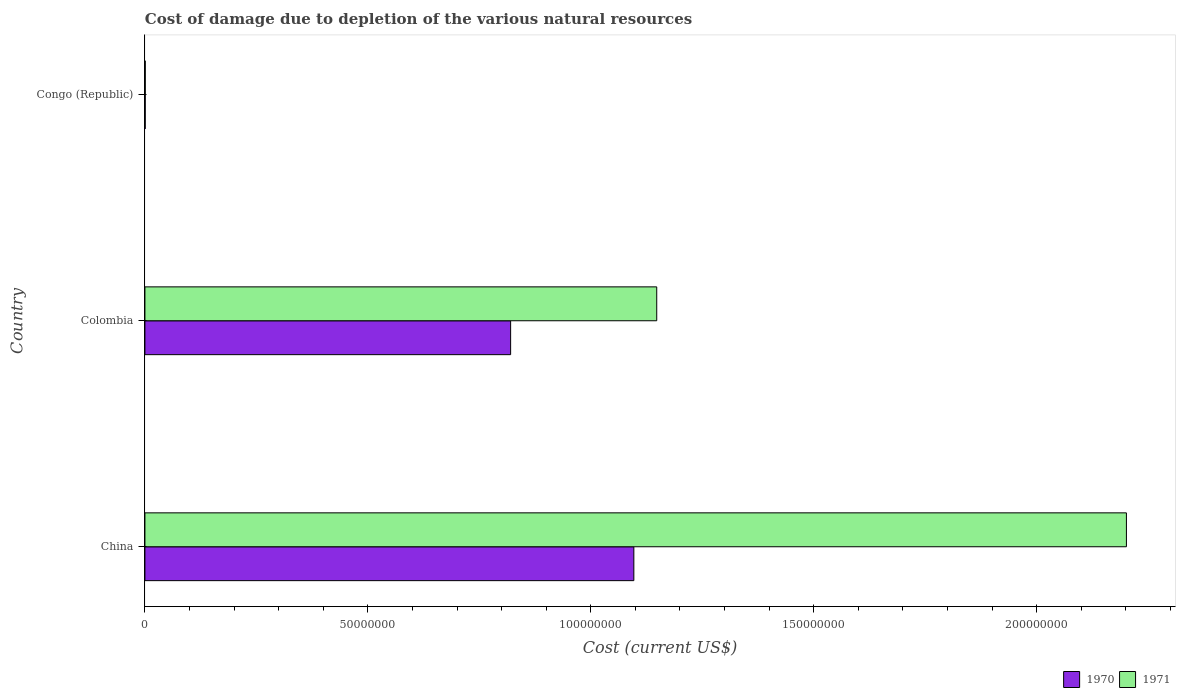Are the number of bars on each tick of the Y-axis equal?
Your answer should be compact. Yes. How many bars are there on the 3rd tick from the top?
Your answer should be compact. 2. What is the label of the 2nd group of bars from the top?
Provide a succinct answer. Colombia. What is the cost of damage caused due to the depletion of various natural resources in 1970 in Congo (Republic)?
Offer a very short reply. 6.34e+04. Across all countries, what is the maximum cost of damage caused due to the depletion of various natural resources in 1971?
Provide a succinct answer. 2.20e+08. Across all countries, what is the minimum cost of damage caused due to the depletion of various natural resources in 1971?
Provide a short and direct response. 7.34e+04. In which country was the cost of damage caused due to the depletion of various natural resources in 1971 maximum?
Your answer should be very brief. China. In which country was the cost of damage caused due to the depletion of various natural resources in 1971 minimum?
Your answer should be very brief. Congo (Republic). What is the total cost of damage caused due to the depletion of various natural resources in 1970 in the graph?
Provide a short and direct response. 1.92e+08. What is the difference between the cost of damage caused due to the depletion of various natural resources in 1971 in Colombia and that in Congo (Republic)?
Offer a terse response. 1.15e+08. What is the difference between the cost of damage caused due to the depletion of various natural resources in 1971 in China and the cost of damage caused due to the depletion of various natural resources in 1970 in Congo (Republic)?
Your answer should be compact. 2.20e+08. What is the average cost of damage caused due to the depletion of various natural resources in 1970 per country?
Offer a terse response. 6.39e+07. What is the difference between the cost of damage caused due to the depletion of various natural resources in 1970 and cost of damage caused due to the depletion of various natural resources in 1971 in Colombia?
Give a very brief answer. -3.28e+07. In how many countries, is the cost of damage caused due to the depletion of various natural resources in 1970 greater than 110000000 US$?
Provide a short and direct response. 0. What is the ratio of the cost of damage caused due to the depletion of various natural resources in 1971 in China to that in Congo (Republic)?
Your answer should be very brief. 2997.27. Is the difference between the cost of damage caused due to the depletion of various natural resources in 1970 in Colombia and Congo (Republic) greater than the difference between the cost of damage caused due to the depletion of various natural resources in 1971 in Colombia and Congo (Republic)?
Ensure brevity in your answer.  No. What is the difference between the highest and the second highest cost of damage caused due to the depletion of various natural resources in 1970?
Your answer should be compact. 2.76e+07. What is the difference between the highest and the lowest cost of damage caused due to the depletion of various natural resources in 1971?
Offer a terse response. 2.20e+08. Is the sum of the cost of damage caused due to the depletion of various natural resources in 1971 in Colombia and Congo (Republic) greater than the maximum cost of damage caused due to the depletion of various natural resources in 1970 across all countries?
Your response must be concise. Yes. What does the 2nd bar from the top in Congo (Republic) represents?
Your answer should be compact. 1970. What does the 1st bar from the bottom in China represents?
Give a very brief answer. 1970. How many bars are there?
Provide a short and direct response. 6. Are all the bars in the graph horizontal?
Your answer should be compact. Yes. How many countries are there in the graph?
Your answer should be compact. 3. Does the graph contain grids?
Ensure brevity in your answer.  No. Where does the legend appear in the graph?
Give a very brief answer. Bottom right. How many legend labels are there?
Your answer should be very brief. 2. How are the legend labels stacked?
Ensure brevity in your answer.  Horizontal. What is the title of the graph?
Ensure brevity in your answer.  Cost of damage due to depletion of the various natural resources. What is the label or title of the X-axis?
Ensure brevity in your answer.  Cost (current US$). What is the label or title of the Y-axis?
Your answer should be compact. Country. What is the Cost (current US$) in 1970 in China?
Offer a terse response. 1.10e+08. What is the Cost (current US$) of 1971 in China?
Provide a succinct answer. 2.20e+08. What is the Cost (current US$) in 1970 in Colombia?
Provide a short and direct response. 8.20e+07. What is the Cost (current US$) of 1971 in Colombia?
Give a very brief answer. 1.15e+08. What is the Cost (current US$) in 1970 in Congo (Republic)?
Offer a terse response. 6.34e+04. What is the Cost (current US$) of 1971 in Congo (Republic)?
Your response must be concise. 7.34e+04. Across all countries, what is the maximum Cost (current US$) of 1970?
Offer a very short reply. 1.10e+08. Across all countries, what is the maximum Cost (current US$) in 1971?
Give a very brief answer. 2.20e+08. Across all countries, what is the minimum Cost (current US$) of 1970?
Give a very brief answer. 6.34e+04. Across all countries, what is the minimum Cost (current US$) in 1971?
Keep it short and to the point. 7.34e+04. What is the total Cost (current US$) of 1970 in the graph?
Provide a short and direct response. 1.92e+08. What is the total Cost (current US$) of 1971 in the graph?
Provide a succinct answer. 3.35e+08. What is the difference between the Cost (current US$) in 1970 in China and that in Colombia?
Your answer should be compact. 2.76e+07. What is the difference between the Cost (current US$) of 1971 in China and that in Colombia?
Your answer should be compact. 1.05e+08. What is the difference between the Cost (current US$) of 1970 in China and that in Congo (Republic)?
Provide a short and direct response. 1.10e+08. What is the difference between the Cost (current US$) of 1971 in China and that in Congo (Republic)?
Ensure brevity in your answer.  2.20e+08. What is the difference between the Cost (current US$) of 1970 in Colombia and that in Congo (Republic)?
Keep it short and to the point. 8.20e+07. What is the difference between the Cost (current US$) of 1971 in Colombia and that in Congo (Republic)?
Your answer should be very brief. 1.15e+08. What is the difference between the Cost (current US$) of 1970 in China and the Cost (current US$) of 1971 in Colombia?
Provide a short and direct response. -5.13e+06. What is the difference between the Cost (current US$) in 1970 in China and the Cost (current US$) in 1971 in Congo (Republic)?
Offer a terse response. 1.10e+08. What is the difference between the Cost (current US$) of 1970 in Colombia and the Cost (current US$) of 1971 in Congo (Republic)?
Keep it short and to the point. 8.19e+07. What is the average Cost (current US$) of 1970 per country?
Make the answer very short. 6.39e+07. What is the average Cost (current US$) in 1971 per country?
Your answer should be compact. 1.12e+08. What is the difference between the Cost (current US$) of 1970 and Cost (current US$) of 1971 in China?
Provide a succinct answer. -1.10e+08. What is the difference between the Cost (current US$) in 1970 and Cost (current US$) in 1971 in Colombia?
Offer a terse response. -3.28e+07. What is the difference between the Cost (current US$) in 1970 and Cost (current US$) in 1971 in Congo (Republic)?
Your response must be concise. -1.00e+04. What is the ratio of the Cost (current US$) in 1970 in China to that in Colombia?
Provide a short and direct response. 1.34. What is the ratio of the Cost (current US$) in 1971 in China to that in Colombia?
Offer a very short reply. 1.92. What is the ratio of the Cost (current US$) in 1970 in China to that in Congo (Republic)?
Offer a terse response. 1728.88. What is the ratio of the Cost (current US$) in 1971 in China to that in Congo (Republic)?
Ensure brevity in your answer.  2997.27. What is the ratio of the Cost (current US$) of 1970 in Colombia to that in Congo (Republic)?
Ensure brevity in your answer.  1293.18. What is the ratio of the Cost (current US$) in 1971 in Colombia to that in Congo (Republic)?
Keep it short and to the point. 1562.98. What is the difference between the highest and the second highest Cost (current US$) of 1970?
Your answer should be compact. 2.76e+07. What is the difference between the highest and the second highest Cost (current US$) of 1971?
Your answer should be very brief. 1.05e+08. What is the difference between the highest and the lowest Cost (current US$) of 1970?
Give a very brief answer. 1.10e+08. What is the difference between the highest and the lowest Cost (current US$) of 1971?
Provide a succinct answer. 2.20e+08. 